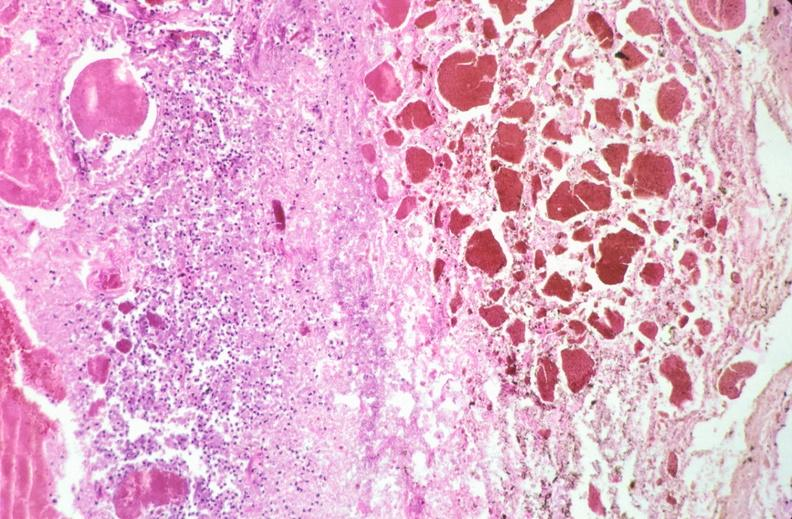what is present?
Answer the question using a single word or phrase. Gastrointestinal 